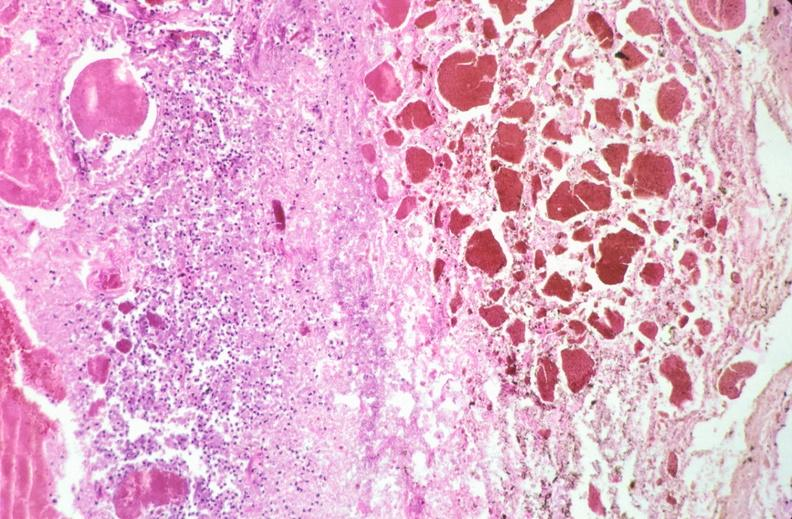what is present?
Answer the question using a single word or phrase. Gastrointestinal 